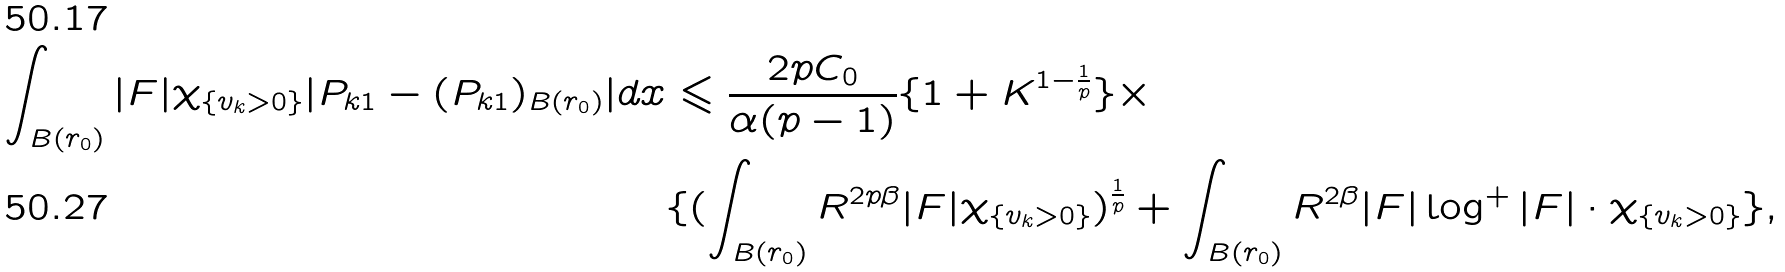<formula> <loc_0><loc_0><loc_500><loc_500>\int _ { B ( r _ { 0 } ) } | F | \chi _ { \{ v _ { k } > 0 \} } | P _ { k 1 } - ( P _ { k 1 } ) _ { B ( r _ { 0 } ) } | d x & \leqslant \frac { 2 p C _ { 0 } } { \alpha ( p - 1 ) } \{ 1 + K ^ { 1 - \frac { 1 } { p } } \} \times \\ & \{ ( \int _ { B ( r _ { 0 } ) } R ^ { 2 p \beta } | F | \chi _ { \{ v _ { k } > 0 \} } ) ^ { \frac { 1 } { p } } + \int _ { B ( r _ { 0 } ) } R ^ { 2 \beta } | F | \log ^ { + } | F | \cdot \chi _ { \{ v _ { k } > 0 \} } \} ,</formula> 